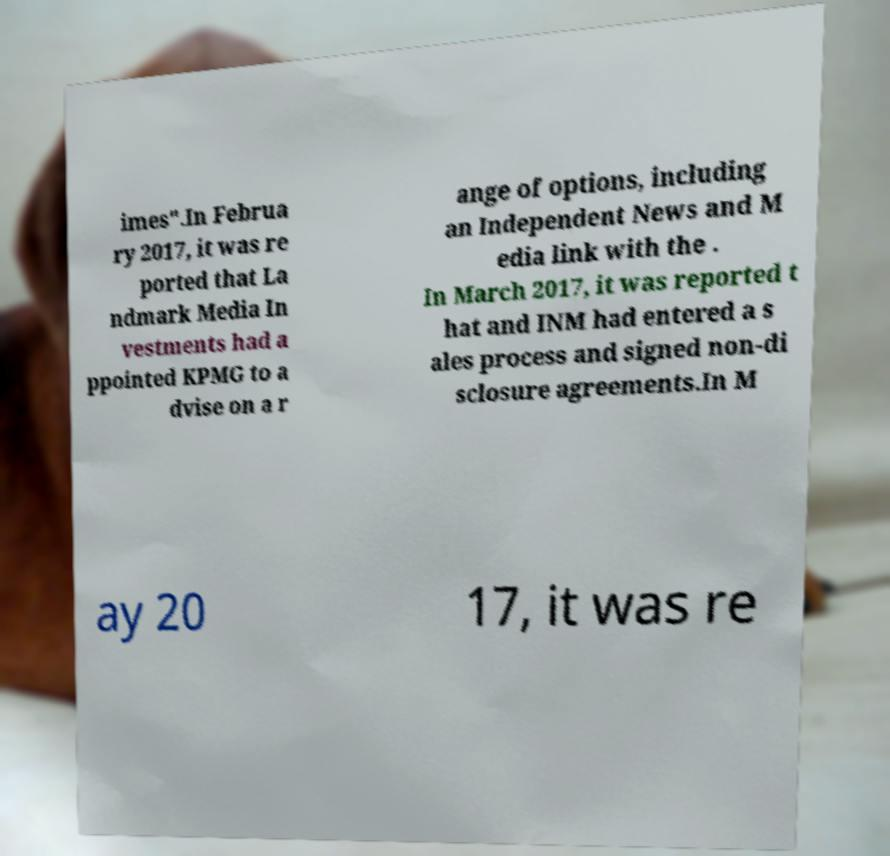Please identify and transcribe the text found in this image. imes".In Februa ry 2017, it was re ported that La ndmark Media In vestments had a ppointed KPMG to a dvise on a r ange of options, including an Independent News and M edia link with the . In March 2017, it was reported t hat and INM had entered a s ales process and signed non-di sclosure agreements.In M ay 20 17, it was re 